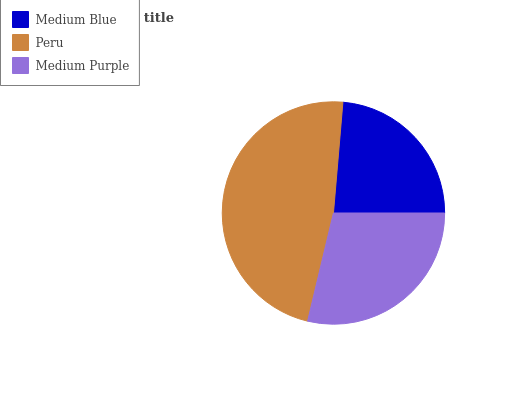Is Medium Blue the minimum?
Answer yes or no. Yes. Is Peru the maximum?
Answer yes or no. Yes. Is Medium Purple the minimum?
Answer yes or no. No. Is Medium Purple the maximum?
Answer yes or no. No. Is Peru greater than Medium Purple?
Answer yes or no. Yes. Is Medium Purple less than Peru?
Answer yes or no. Yes. Is Medium Purple greater than Peru?
Answer yes or no. No. Is Peru less than Medium Purple?
Answer yes or no. No. Is Medium Purple the high median?
Answer yes or no. Yes. Is Medium Purple the low median?
Answer yes or no. Yes. Is Peru the high median?
Answer yes or no. No. Is Medium Blue the low median?
Answer yes or no. No. 